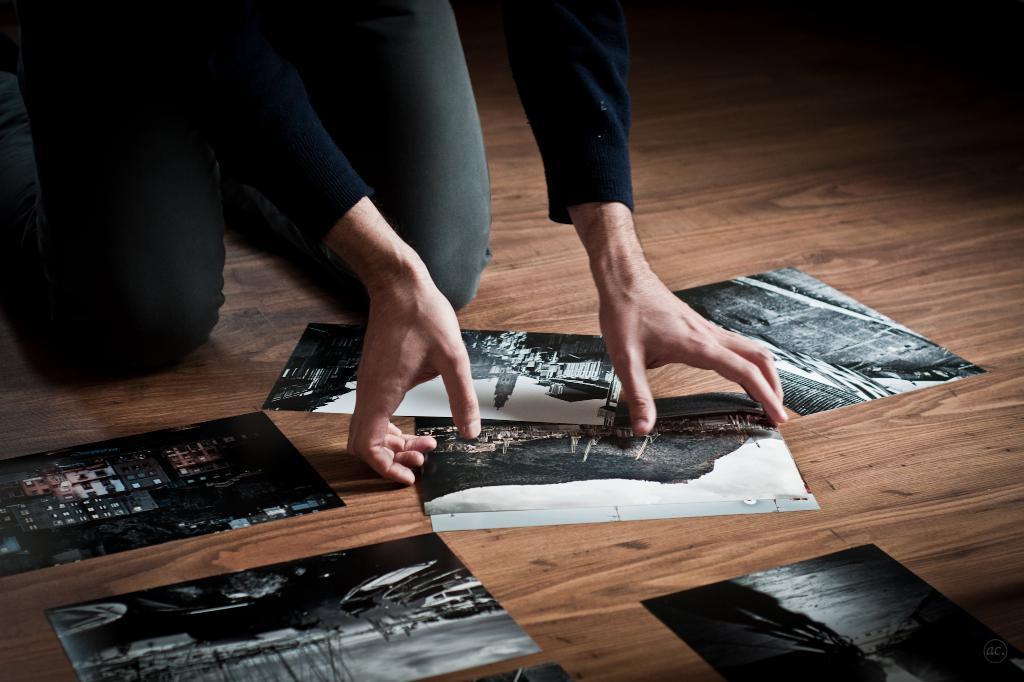Describe this image in one or two sentences. In this image there is one person sitting at top left side of this image and there are some photos kept on this floor and as we can see there is a floor in the background. 